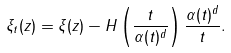Convert formula to latex. <formula><loc_0><loc_0><loc_500><loc_500>\xi _ { t } ( z ) = \xi ( z ) - H \left ( \frac { t } { \alpha ( t ) ^ { d } } \right ) \frac { \alpha ( t ) ^ { d } } { t } .</formula> 